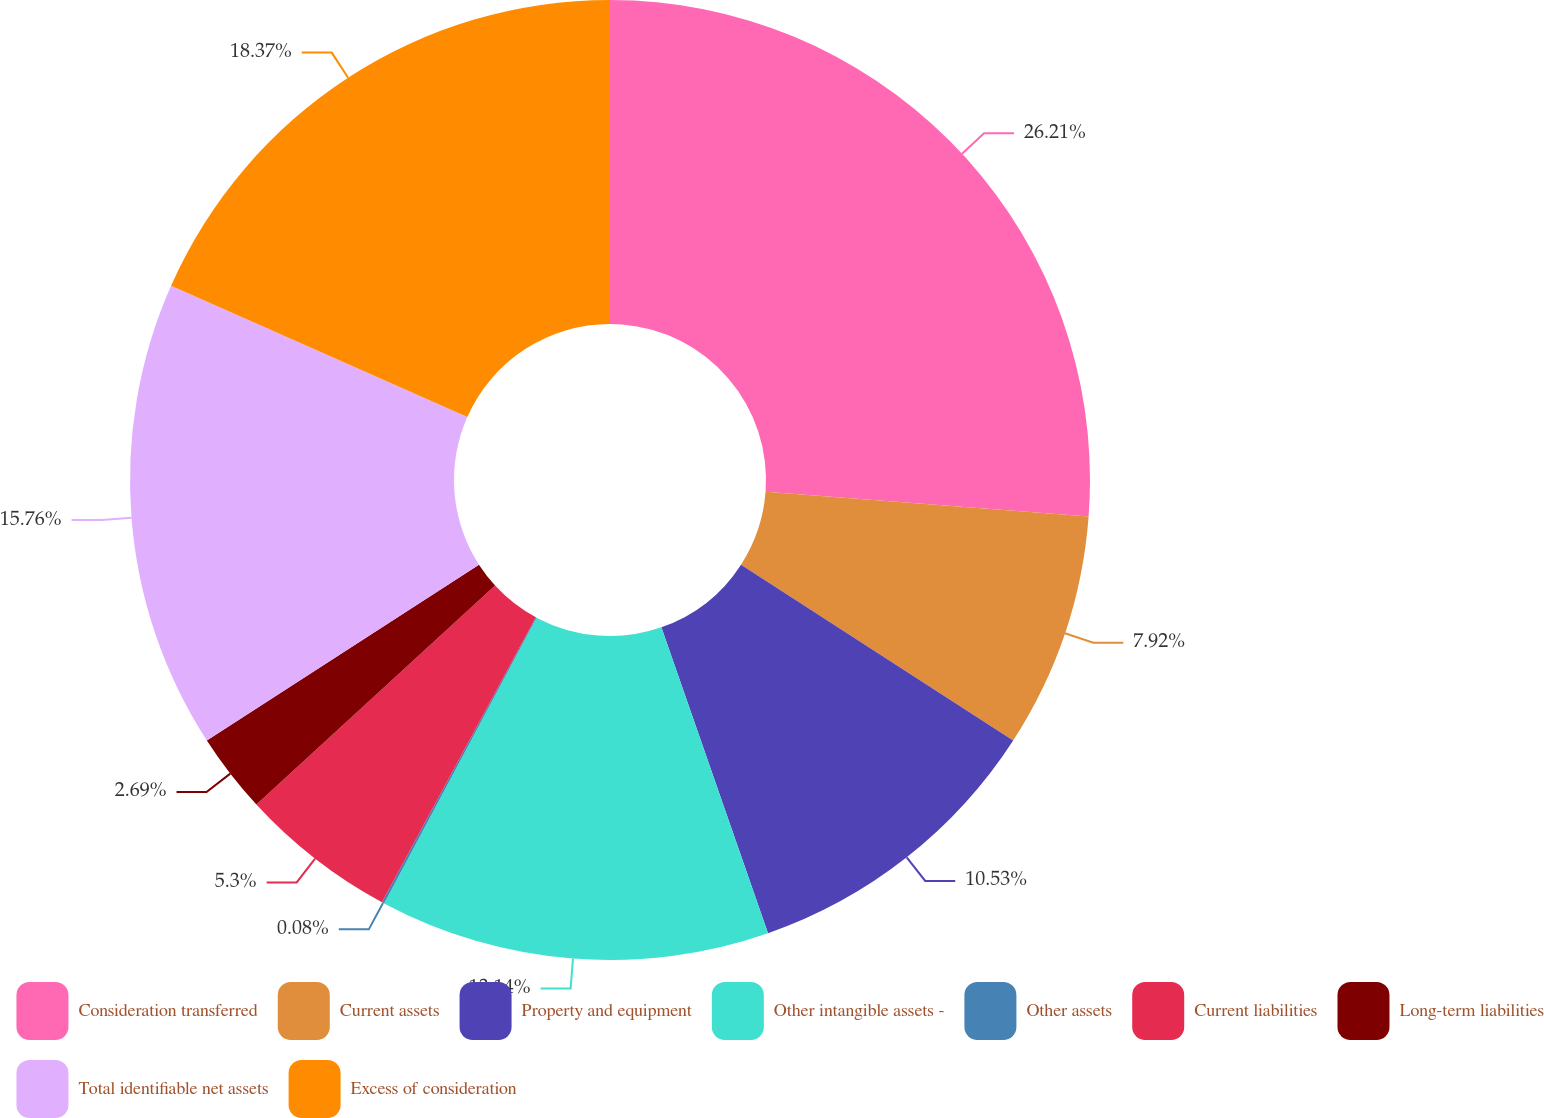<chart> <loc_0><loc_0><loc_500><loc_500><pie_chart><fcel>Consideration transferred<fcel>Current assets<fcel>Property and equipment<fcel>Other intangible assets -<fcel>Other assets<fcel>Current liabilities<fcel>Long-term liabilities<fcel>Total identifiable net assets<fcel>Excess of consideration<nl><fcel>26.21%<fcel>7.92%<fcel>10.53%<fcel>13.14%<fcel>0.08%<fcel>5.3%<fcel>2.69%<fcel>15.76%<fcel>18.37%<nl></chart> 